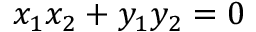<formula> <loc_0><loc_0><loc_500><loc_500>x _ { 1 } x _ { 2 } + y _ { 1 } y _ { 2 } = 0</formula> 